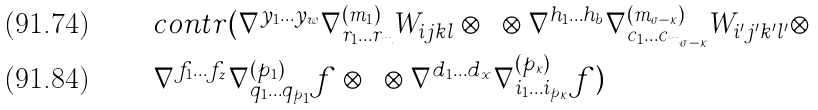<formula> <loc_0><loc_0><loc_500><loc_500>& c o n t r ( \nabla ^ { y _ { 1 } \dots y _ { w } } \nabla ^ { ( m _ { 1 } ) } _ { r _ { 1 } \dots r _ { m } } W _ { i j k l } \otimes \dots \otimes \nabla ^ { h _ { 1 } \dots h _ { b } } \nabla ^ { ( m _ { \sigma - \kappa } ) } _ { c _ { 1 } \dots c _ { m _ { \sigma - \kappa } } } W _ { i ^ { \prime } j ^ { \prime } k ^ { \prime } l ^ { \prime } } \otimes \\ & \nabla ^ { f _ { 1 } \dots f _ { z } } \nabla ^ { ( p _ { 1 } ) } _ { q _ { 1 } \dots q _ { p _ { 1 } } } f \otimes \dots \otimes \nabla ^ { d _ { 1 } \dots d _ { x } } \nabla ^ { ( p _ { \kappa } ) } _ { i _ { 1 } \dots i _ { p _ { \kappa } } } f )</formula> 